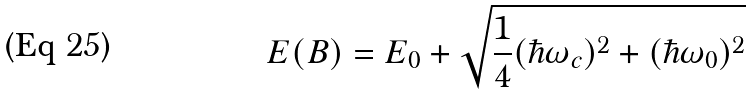<formula> <loc_0><loc_0><loc_500><loc_500>E ( B ) = E _ { 0 } + \sqrt { \frac { 1 } { 4 } ( \hbar { \omega } _ { c } ) ^ { 2 } + ( \hbar { \omega } _ { 0 } ) ^ { 2 } }</formula> 